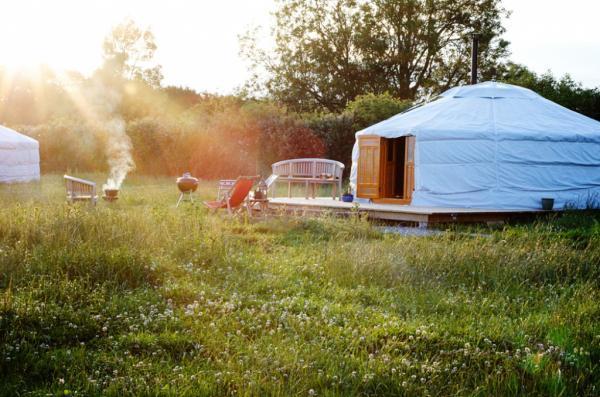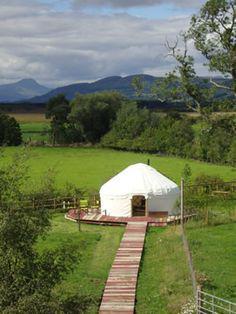The first image is the image on the left, the second image is the image on the right. For the images shown, is this caption "the huts are not all white but have color" true? Answer yes or no. No. The first image is the image on the left, the second image is the image on the right. Considering the images on both sides, is "At least one image contains 3 or more yurts." valid? Answer yes or no. No. 